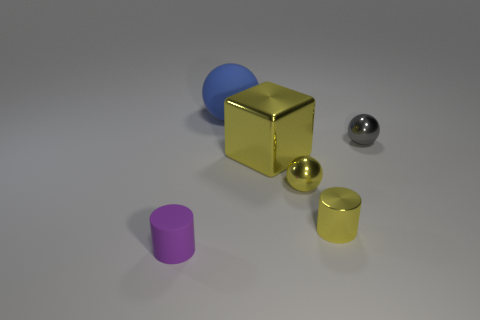What number of red metallic cubes are the same size as the gray sphere?
Give a very brief answer. 0. Is there a small cylinder that is on the left side of the gray shiny object that is right of the small purple cylinder?
Provide a succinct answer. Yes. How many gray objects are big metallic cubes or cylinders?
Your answer should be very brief. 0. What color is the block?
Keep it short and to the point. Yellow. What is the size of the cube that is the same material as the gray ball?
Provide a succinct answer. Large. How many small metallic things have the same shape as the small purple rubber object?
Your response must be concise. 1. How big is the rubber thing behind the tiny cylinder that is on the left side of the blue ball?
Keep it short and to the point. Large. There is a thing that is the same size as the yellow metallic cube; what is its material?
Offer a very short reply. Rubber. Are there any things that have the same material as the purple cylinder?
Your answer should be very brief. Yes. The matte object on the right side of the tiny object in front of the cylinder to the right of the purple rubber cylinder is what color?
Give a very brief answer. Blue. 